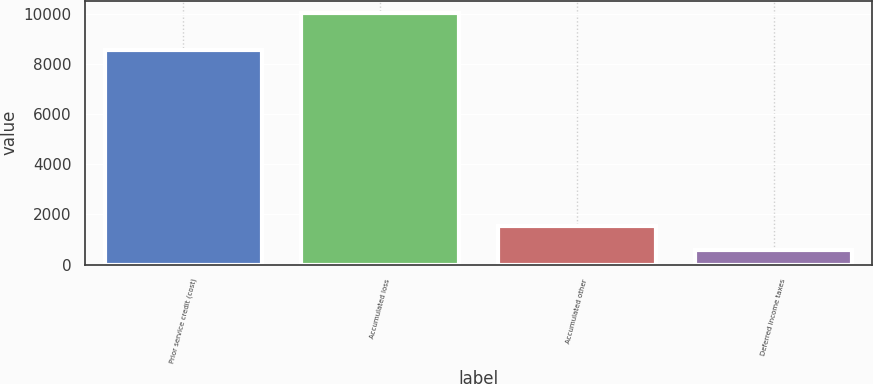<chart> <loc_0><loc_0><loc_500><loc_500><bar_chart><fcel>Prior service credit (cost)<fcel>Accumulated loss<fcel>Accumulated other<fcel>Deferred income taxes<nl><fcel>8535<fcel>10012<fcel>1533.1<fcel>591<nl></chart> 